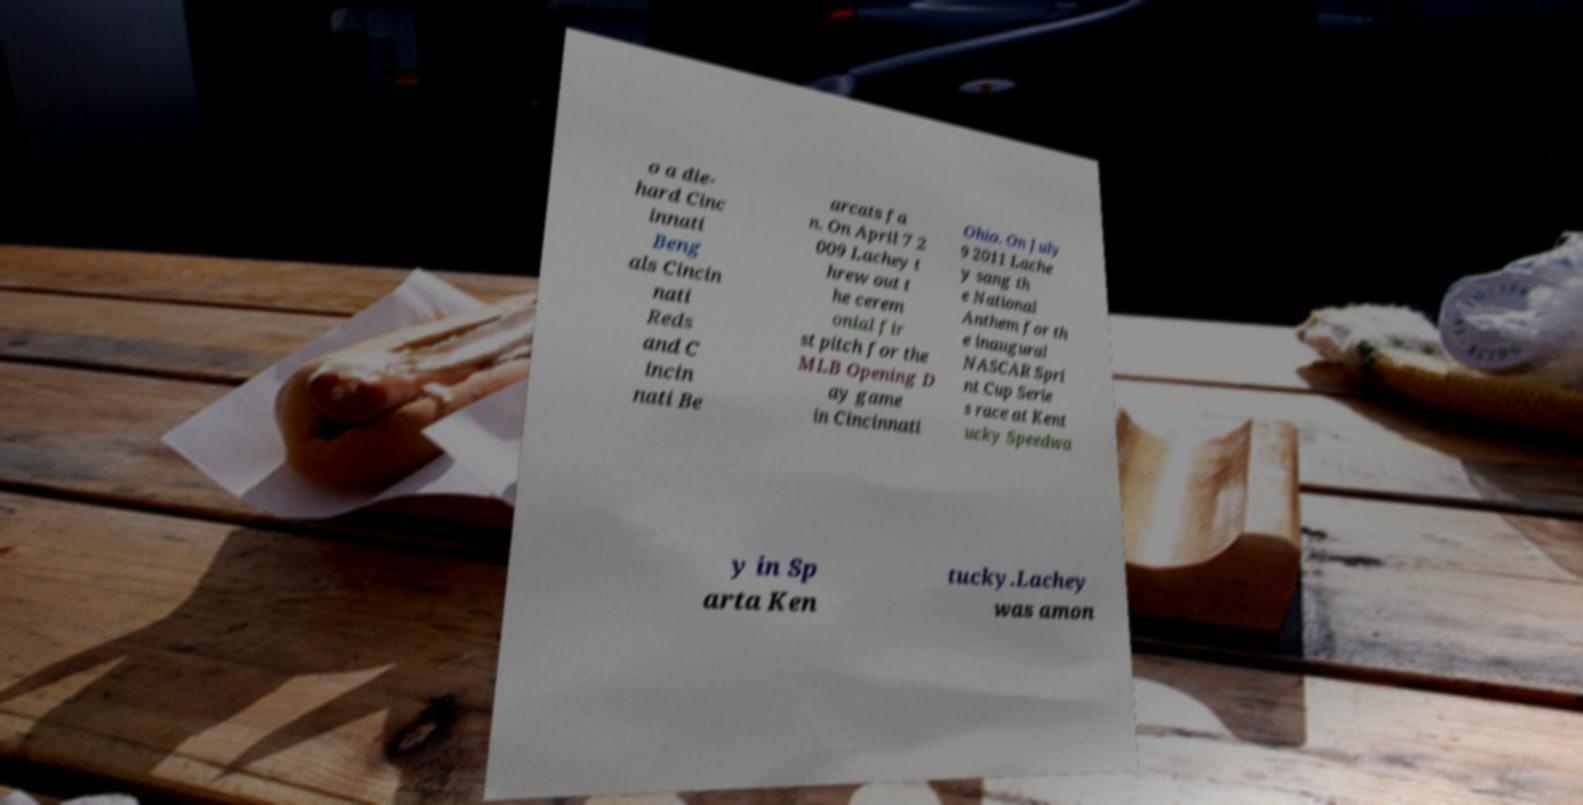Can you read and provide the text displayed in the image?This photo seems to have some interesting text. Can you extract and type it out for me? o a die- hard Cinc innati Beng als Cincin nati Reds and C incin nati Be arcats fa n. On April 7 2 009 Lachey t hrew out t he cerem onial fir st pitch for the MLB Opening D ay game in Cincinnati Ohio. On July 9 2011 Lache y sang th e National Anthem for th e inaugural NASCAR Spri nt Cup Serie s race at Kent ucky Speedwa y in Sp arta Ken tucky.Lachey was amon 